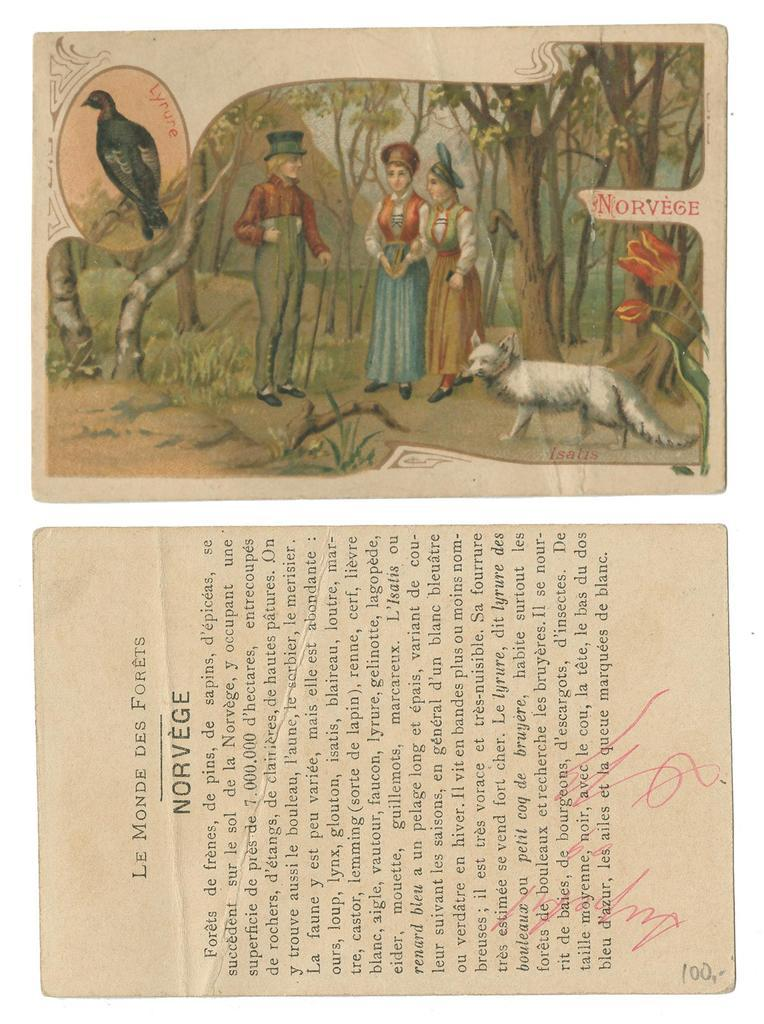How many papers are visible in the image? There are two papers in the image. What distinguishing features can be seen on the papers? The papers have page numbers, a photo on one of the papers, signatures, and paragraphs. What might the papers be related to, given the presence of signatures and paragraphs? The papers might be related to a legal document, contract, or agreement. What type of wine can be seen in the photo on one of the papers? There is no wine visible in the image, and the photo on one of the papers does not depict any wine. 